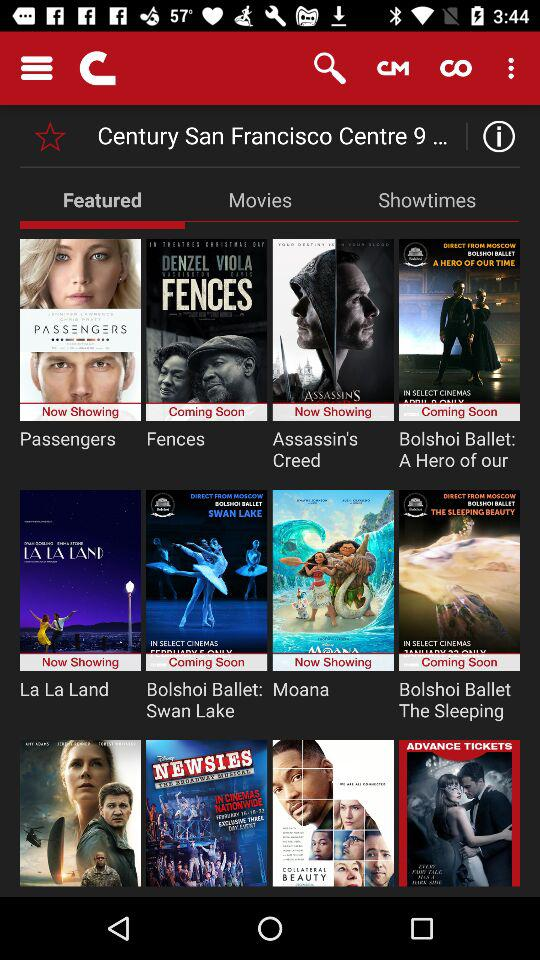What are the featured movies? The featured movies are "Passengers", "Fences", "Assassin's Creed", "Bolshoi Ballet: A Hero of our", "La La Land", "Bolshoi Ballet: Swan Lake", "Moana" and "Bolshoi Ballet The Sleeping". 